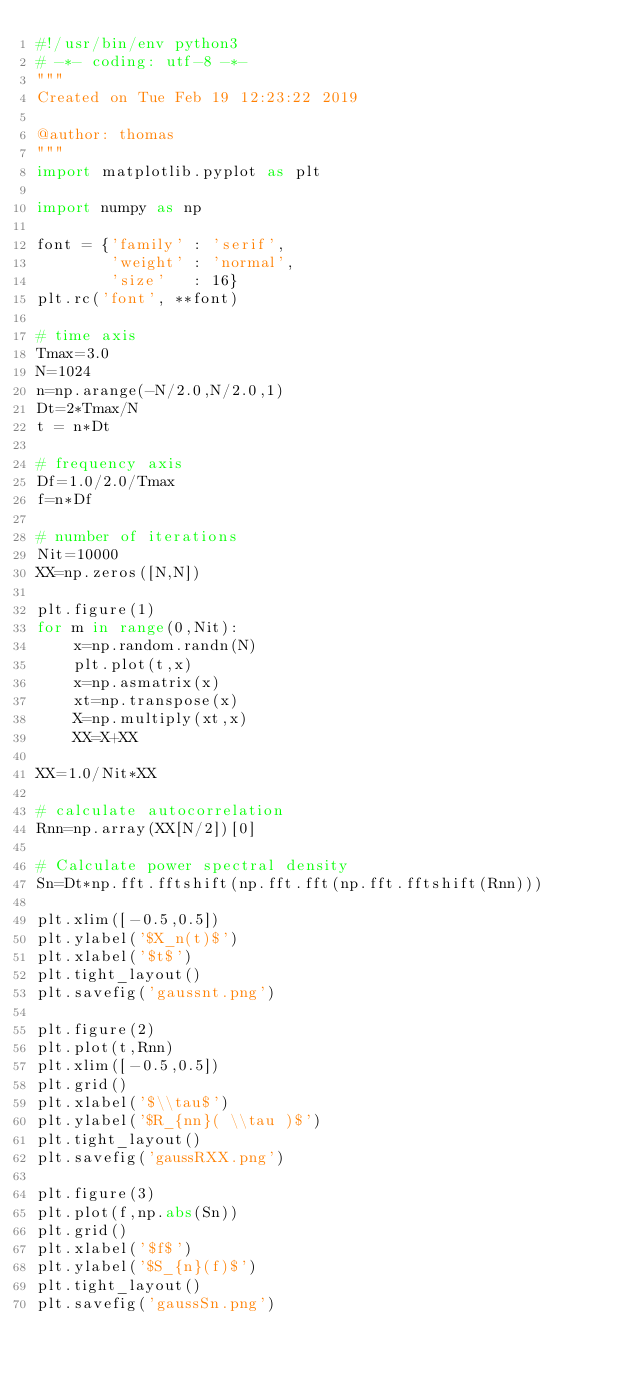Convert code to text. <code><loc_0><loc_0><loc_500><loc_500><_Python_>#!/usr/bin/env python3
# -*- coding: utf-8 -*-
"""
Created on Tue Feb 19 12:23:22 2019

@author: thomas
"""
import matplotlib.pyplot as plt

import numpy as np

font = {'family' : 'serif',
        'weight' : 'normal',
        'size'   : 16}	
plt.rc('font', **font)

# time axis
Tmax=3.0
N=1024
n=np.arange(-N/2.0,N/2.0,1)
Dt=2*Tmax/N
t = n*Dt

# frequency axis
Df=1.0/2.0/Tmax
f=n*Df

# number of iterations
Nit=10000
XX=np.zeros([N,N])

plt.figure(1)    
for m in range(0,Nit):
    x=np.random.randn(N)
    plt.plot(t,x)
    x=np.asmatrix(x)
    xt=np.transpose(x)
    X=np.multiply(xt,x)
    XX=X+XX
    
XX=1.0/Nit*XX

# calculate autocorrelation
Rnn=np.array(XX[N/2])[0]

# Calculate power spectral density
Sn=Dt*np.fft.fftshift(np.fft.fft(np.fft.fftshift(Rnn)))

plt.xlim([-0.5,0.5])
plt.ylabel('$X_n(t)$')
plt.xlabel('$t$')
plt.tight_layout()
plt.savefig('gaussnt.png')

plt.figure(2)    
plt.plot(t,Rnn)
plt.xlim([-0.5,0.5])
plt.grid()
plt.xlabel('$\\tau$')
plt.ylabel('$R_{nn}( \\tau )$')
plt.tight_layout()
plt.savefig('gaussRXX.png')

plt.figure(3)    
plt.plot(f,np.abs(Sn))
plt.grid()
plt.xlabel('$f$')
plt.ylabel('$S_{n}(f)$')
plt.tight_layout()
plt.savefig('gaussSn.png')

</code> 